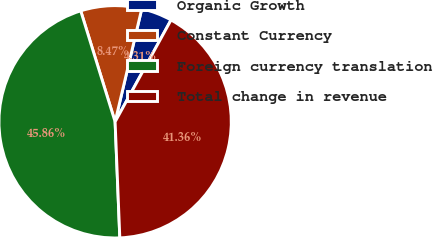Convert chart to OTSL. <chart><loc_0><loc_0><loc_500><loc_500><pie_chart><fcel>Organic Growth<fcel>Constant Currency<fcel>Foreign currency translation<fcel>Total change in revenue<nl><fcel>4.31%<fcel>8.47%<fcel>45.86%<fcel>41.36%<nl></chart> 